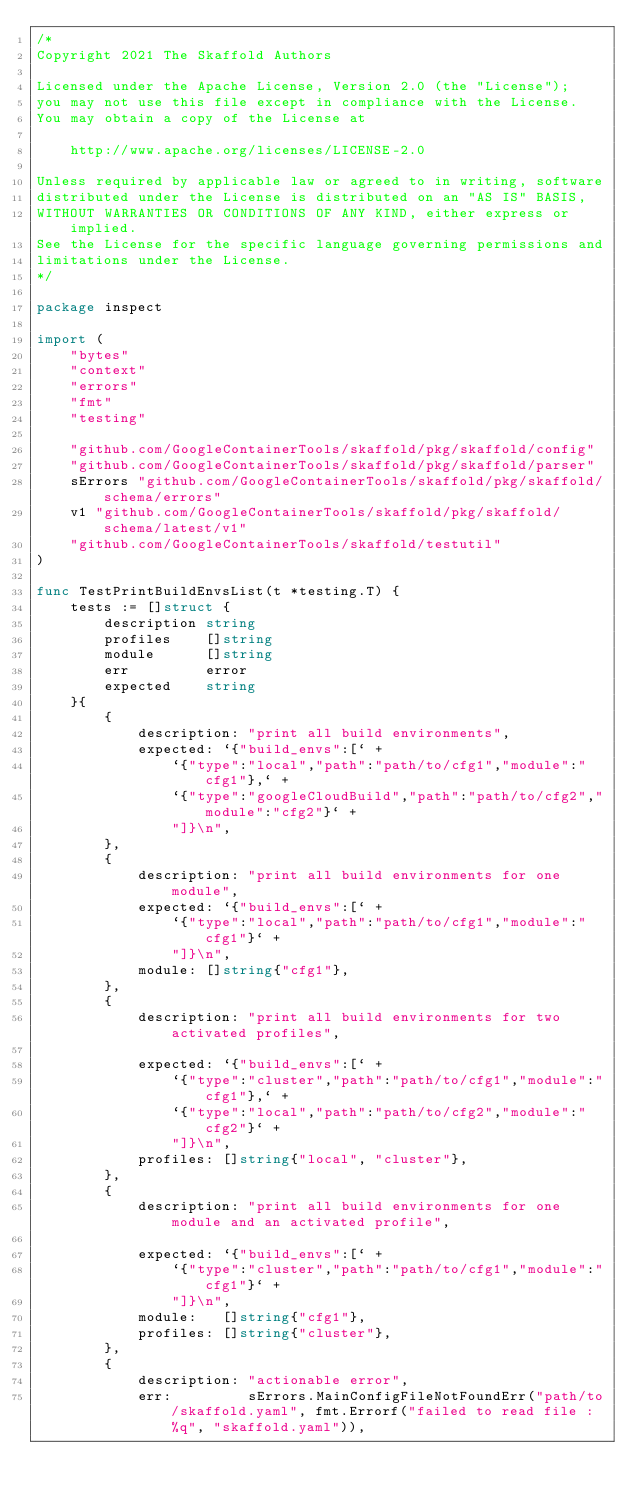<code> <loc_0><loc_0><loc_500><loc_500><_Go_>/*
Copyright 2021 The Skaffold Authors

Licensed under the Apache License, Version 2.0 (the "License");
you may not use this file except in compliance with the License.
You may obtain a copy of the License at

    http://www.apache.org/licenses/LICENSE-2.0

Unless required by applicable law or agreed to in writing, software
distributed under the License is distributed on an "AS IS" BASIS,
WITHOUT WARRANTIES OR CONDITIONS OF ANY KIND, either express or implied.
See the License for the specific language governing permissions and
limitations under the License.
*/

package inspect

import (
	"bytes"
	"context"
	"errors"
	"fmt"
	"testing"

	"github.com/GoogleContainerTools/skaffold/pkg/skaffold/config"
	"github.com/GoogleContainerTools/skaffold/pkg/skaffold/parser"
	sErrors "github.com/GoogleContainerTools/skaffold/pkg/skaffold/schema/errors"
	v1 "github.com/GoogleContainerTools/skaffold/pkg/skaffold/schema/latest/v1"
	"github.com/GoogleContainerTools/skaffold/testutil"
)

func TestPrintBuildEnvsList(t *testing.T) {
	tests := []struct {
		description string
		profiles    []string
		module      []string
		err         error
		expected    string
	}{
		{
			description: "print all build environments",
			expected: `{"build_envs":[` +
				`{"type":"local","path":"path/to/cfg1","module":"cfg1"},` +
				`{"type":"googleCloudBuild","path":"path/to/cfg2","module":"cfg2"}` +
				"]}\n",
		},
		{
			description: "print all build environments for one module",
			expected: `{"build_envs":[` +
				`{"type":"local","path":"path/to/cfg1","module":"cfg1"}` +
				"]}\n",
			module: []string{"cfg1"},
		},
		{
			description: "print all build environments for two activated profiles",

			expected: `{"build_envs":[` +
				`{"type":"cluster","path":"path/to/cfg1","module":"cfg1"},` +
				`{"type":"local","path":"path/to/cfg2","module":"cfg2"}` +
				"]}\n",
			profiles: []string{"local", "cluster"},
		},
		{
			description: "print all build environments for one module and an activated profile",

			expected: `{"build_envs":[` +
				`{"type":"cluster","path":"path/to/cfg1","module":"cfg1"}` +
				"]}\n",
			module:   []string{"cfg1"},
			profiles: []string{"cluster"},
		},
		{
			description: "actionable error",
			err:         sErrors.MainConfigFileNotFoundErr("path/to/skaffold.yaml", fmt.Errorf("failed to read file : %q", "skaffold.yaml")),</code> 